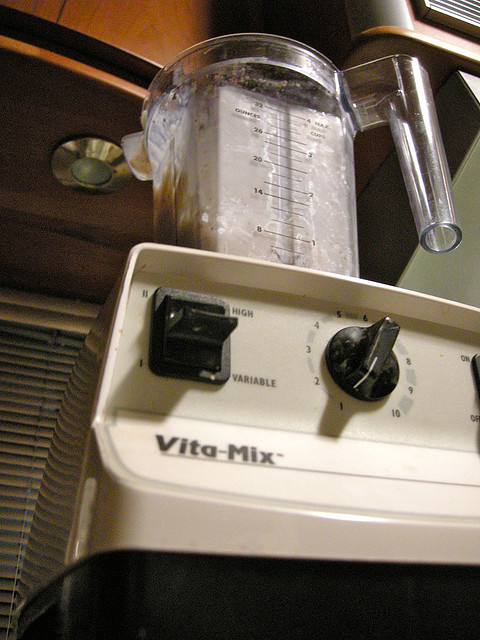Please transcribe the text information in this image. HIGH Vita-Mix 2 3 3 2 20 14 11 OFF ON 4 5 6 8 9 10 